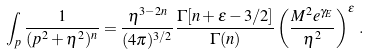<formula> <loc_0><loc_0><loc_500><loc_500>\int _ { p } \frac { 1 } { ( p ^ { 2 } + \eta ^ { 2 } ) ^ { n } } = \frac { \eta ^ { 3 - 2 n } } { ( 4 \pi ) ^ { 3 / 2 } } \frac { \Gamma [ n + \epsilon - 3 / 2 ] } { \Gamma ( n ) } \left ( \frac { M ^ { 2 } e ^ { \gamma _ { E } } } { \eta ^ { 2 } } \right ) ^ { \epsilon } \, .</formula> 